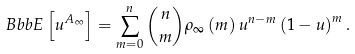<formula> <loc_0><loc_0><loc_500><loc_500>\ B b b { E } \left [ u ^ { A _ { \infty } } \right ] = \sum _ { m = 0 } ^ { n } \binom { n } { m } \rho _ { \infty } \left ( m \right ) u ^ { n - m } \left ( 1 - u \right ) ^ { m } .</formula> 